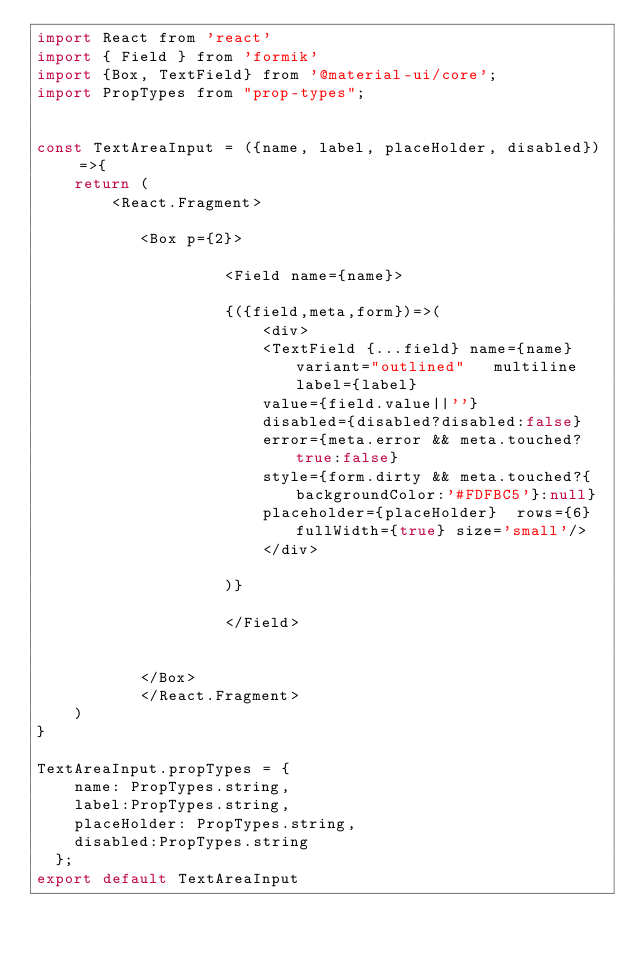Convert code to text. <code><loc_0><loc_0><loc_500><loc_500><_JavaScript_>import React from 'react'
import { Field } from 'formik'
import {Box, TextField} from '@material-ui/core';
import PropTypes from "prop-types";


const TextAreaInput = ({name, label, placeHolder, disabled}) =>{
    return (
        <React.Fragment>

           <Box p={2}>

                    <Field name={name}>
 
                    {({field,meta,form})=>(
                        <div>
                        <TextField {...field} name={name} variant="outlined"   multiline label={label}
                        value={field.value||''}
                        disabled={disabled?disabled:false}
                        error={meta.error && meta.touched?true:false}
                        style={form.dirty && meta.touched?{backgroundColor:'#FDFBC5'}:null}
                        placeholder={placeHolder}  rows={6} fullWidth={true} size='small'/>     
                        </div> 
                     
                    )}
                    
                    </Field>      

               
           </Box>
           </React.Fragment>
    )
}

TextAreaInput.propTypes = {
    name: PropTypes.string,
    label:PropTypes.string,
    placeHolder: PropTypes.string,
    disabled:PropTypes.string
  };
export default TextAreaInput</code> 